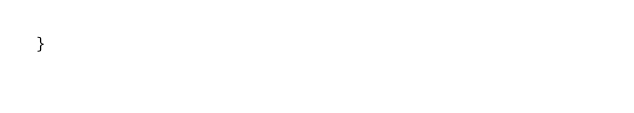<code> <loc_0><loc_0><loc_500><loc_500><_TypeScript_>}
</code> 